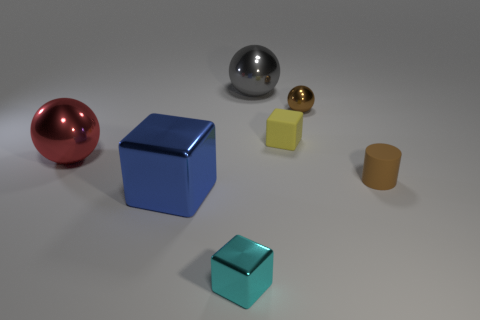What shape is the matte object that is the same color as the small metallic sphere?
Offer a very short reply. Cylinder. Is the small rubber cube the same color as the matte cylinder?
Offer a very short reply. No. Is the number of tiny cylinders that are left of the large gray metal thing greater than the number of tiny brown matte cylinders behind the large red sphere?
Keep it short and to the point. No. Do the metallic sphere that is right of the big gray sphere and the tiny rubber block have the same color?
Your answer should be compact. No. Is there anything else that has the same color as the cylinder?
Make the answer very short. Yes. Are there more big shiny things right of the small cyan block than blue metallic objects?
Ensure brevity in your answer.  No. Do the blue object and the brown matte object have the same size?
Provide a short and direct response. No. What is the material of the brown thing that is the same shape as the big red metal thing?
Offer a terse response. Metal. What number of red objects are either tiny metallic balls or balls?
Keep it short and to the point. 1. There is a big blue thing that is behind the small cyan metallic object; what is it made of?
Your answer should be compact. Metal. 